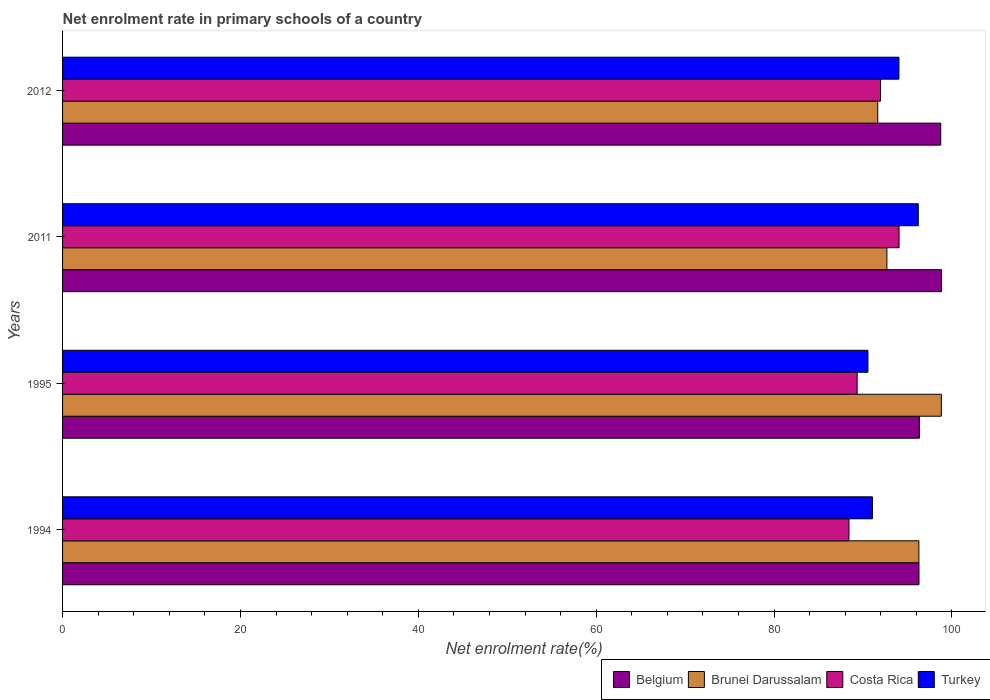How many groups of bars are there?
Make the answer very short. 4. Are the number of bars per tick equal to the number of legend labels?
Provide a short and direct response. Yes. Are the number of bars on each tick of the Y-axis equal?
Provide a succinct answer. Yes. In how many cases, is the number of bars for a given year not equal to the number of legend labels?
Provide a short and direct response. 0. What is the net enrolment rate in primary schools in Belgium in 1994?
Offer a very short reply. 96.3. Across all years, what is the maximum net enrolment rate in primary schools in Brunei Darussalam?
Give a very brief answer. 98.81. Across all years, what is the minimum net enrolment rate in primary schools in Turkey?
Keep it short and to the point. 90.56. What is the total net enrolment rate in primary schools in Turkey in the graph?
Give a very brief answer. 371.87. What is the difference between the net enrolment rate in primary schools in Belgium in 1994 and that in 2011?
Provide a succinct answer. -2.54. What is the difference between the net enrolment rate in primary schools in Turkey in 1995 and the net enrolment rate in primary schools in Brunei Darussalam in 2012?
Make the answer very short. -1.11. What is the average net enrolment rate in primary schools in Turkey per year?
Provide a short and direct response. 92.97. In the year 2012, what is the difference between the net enrolment rate in primary schools in Belgium and net enrolment rate in primary schools in Brunei Darussalam?
Your answer should be very brief. 7.08. What is the ratio of the net enrolment rate in primary schools in Costa Rica in 1995 to that in 2011?
Your answer should be very brief. 0.95. Is the difference between the net enrolment rate in primary schools in Belgium in 1995 and 2012 greater than the difference between the net enrolment rate in primary schools in Brunei Darussalam in 1995 and 2012?
Give a very brief answer. No. What is the difference between the highest and the second highest net enrolment rate in primary schools in Brunei Darussalam?
Your answer should be very brief. 2.53. What is the difference between the highest and the lowest net enrolment rate in primary schools in Belgium?
Provide a succinct answer. 2.54. In how many years, is the net enrolment rate in primary schools in Turkey greater than the average net enrolment rate in primary schools in Turkey taken over all years?
Your response must be concise. 2. Is the sum of the net enrolment rate in primary schools in Turkey in 1994 and 2012 greater than the maximum net enrolment rate in primary schools in Belgium across all years?
Keep it short and to the point. Yes. Is it the case that in every year, the sum of the net enrolment rate in primary schools in Costa Rica and net enrolment rate in primary schools in Turkey is greater than the sum of net enrolment rate in primary schools in Brunei Darussalam and net enrolment rate in primary schools in Belgium?
Provide a short and direct response. No. What does the 2nd bar from the top in 1994 represents?
Keep it short and to the point. Costa Rica. What does the 3rd bar from the bottom in 2011 represents?
Keep it short and to the point. Costa Rica. Is it the case that in every year, the sum of the net enrolment rate in primary schools in Belgium and net enrolment rate in primary schools in Turkey is greater than the net enrolment rate in primary schools in Brunei Darussalam?
Your answer should be compact. Yes. How many bars are there?
Keep it short and to the point. 16. Are all the bars in the graph horizontal?
Keep it short and to the point. Yes. What is the difference between two consecutive major ticks on the X-axis?
Your answer should be very brief. 20. Are the values on the major ticks of X-axis written in scientific E-notation?
Your answer should be very brief. No. Where does the legend appear in the graph?
Ensure brevity in your answer.  Bottom right. How are the legend labels stacked?
Give a very brief answer. Horizontal. What is the title of the graph?
Your answer should be compact. Net enrolment rate in primary schools of a country. What is the label or title of the X-axis?
Keep it short and to the point. Net enrolment rate(%). What is the label or title of the Y-axis?
Your response must be concise. Years. What is the Net enrolment rate(%) in Belgium in 1994?
Your answer should be compact. 96.3. What is the Net enrolment rate(%) in Brunei Darussalam in 1994?
Offer a very short reply. 96.28. What is the Net enrolment rate(%) in Costa Rica in 1994?
Ensure brevity in your answer.  88.42. What is the Net enrolment rate(%) in Turkey in 1994?
Give a very brief answer. 91.06. What is the Net enrolment rate(%) in Belgium in 1995?
Provide a succinct answer. 96.34. What is the Net enrolment rate(%) in Brunei Darussalam in 1995?
Ensure brevity in your answer.  98.81. What is the Net enrolment rate(%) of Costa Rica in 1995?
Make the answer very short. 89.34. What is the Net enrolment rate(%) of Turkey in 1995?
Keep it short and to the point. 90.56. What is the Net enrolment rate(%) in Belgium in 2011?
Offer a terse response. 98.83. What is the Net enrolment rate(%) of Brunei Darussalam in 2011?
Your answer should be very brief. 92.69. What is the Net enrolment rate(%) of Costa Rica in 2011?
Your response must be concise. 94.06. What is the Net enrolment rate(%) in Turkey in 2011?
Your answer should be very brief. 96.22. What is the Net enrolment rate(%) in Belgium in 2012?
Ensure brevity in your answer.  98.74. What is the Net enrolment rate(%) of Brunei Darussalam in 2012?
Provide a short and direct response. 91.66. What is the Net enrolment rate(%) of Costa Rica in 2012?
Keep it short and to the point. 91.98. What is the Net enrolment rate(%) of Turkey in 2012?
Make the answer very short. 94.04. Across all years, what is the maximum Net enrolment rate(%) in Belgium?
Ensure brevity in your answer.  98.83. Across all years, what is the maximum Net enrolment rate(%) in Brunei Darussalam?
Offer a very short reply. 98.81. Across all years, what is the maximum Net enrolment rate(%) of Costa Rica?
Make the answer very short. 94.06. Across all years, what is the maximum Net enrolment rate(%) of Turkey?
Keep it short and to the point. 96.22. Across all years, what is the minimum Net enrolment rate(%) of Belgium?
Provide a succinct answer. 96.3. Across all years, what is the minimum Net enrolment rate(%) in Brunei Darussalam?
Your response must be concise. 91.66. Across all years, what is the minimum Net enrolment rate(%) of Costa Rica?
Provide a short and direct response. 88.42. Across all years, what is the minimum Net enrolment rate(%) in Turkey?
Your response must be concise. 90.56. What is the total Net enrolment rate(%) in Belgium in the graph?
Give a very brief answer. 390.21. What is the total Net enrolment rate(%) in Brunei Darussalam in the graph?
Provide a short and direct response. 379.44. What is the total Net enrolment rate(%) of Costa Rica in the graph?
Make the answer very short. 363.8. What is the total Net enrolment rate(%) of Turkey in the graph?
Your answer should be very brief. 371.87. What is the difference between the Net enrolment rate(%) of Belgium in 1994 and that in 1995?
Offer a terse response. -0.05. What is the difference between the Net enrolment rate(%) in Brunei Darussalam in 1994 and that in 1995?
Provide a succinct answer. -2.53. What is the difference between the Net enrolment rate(%) in Costa Rica in 1994 and that in 1995?
Your response must be concise. -0.92. What is the difference between the Net enrolment rate(%) of Turkey in 1994 and that in 1995?
Provide a short and direct response. 0.5. What is the difference between the Net enrolment rate(%) in Belgium in 1994 and that in 2011?
Give a very brief answer. -2.54. What is the difference between the Net enrolment rate(%) in Brunei Darussalam in 1994 and that in 2011?
Offer a very short reply. 3.6. What is the difference between the Net enrolment rate(%) in Costa Rica in 1994 and that in 2011?
Your answer should be very brief. -5.63. What is the difference between the Net enrolment rate(%) in Turkey in 1994 and that in 2011?
Provide a short and direct response. -5.16. What is the difference between the Net enrolment rate(%) of Belgium in 1994 and that in 2012?
Your answer should be very brief. -2.45. What is the difference between the Net enrolment rate(%) in Brunei Darussalam in 1994 and that in 2012?
Give a very brief answer. 4.62. What is the difference between the Net enrolment rate(%) of Costa Rica in 1994 and that in 2012?
Your answer should be very brief. -3.55. What is the difference between the Net enrolment rate(%) in Turkey in 1994 and that in 2012?
Provide a succinct answer. -2.98. What is the difference between the Net enrolment rate(%) of Belgium in 1995 and that in 2011?
Your answer should be very brief. -2.49. What is the difference between the Net enrolment rate(%) of Brunei Darussalam in 1995 and that in 2011?
Give a very brief answer. 6.12. What is the difference between the Net enrolment rate(%) in Costa Rica in 1995 and that in 2011?
Your response must be concise. -4.71. What is the difference between the Net enrolment rate(%) of Turkey in 1995 and that in 2011?
Your answer should be compact. -5.66. What is the difference between the Net enrolment rate(%) of Belgium in 1995 and that in 2012?
Offer a terse response. -2.4. What is the difference between the Net enrolment rate(%) in Brunei Darussalam in 1995 and that in 2012?
Your response must be concise. 7.15. What is the difference between the Net enrolment rate(%) in Costa Rica in 1995 and that in 2012?
Offer a very short reply. -2.63. What is the difference between the Net enrolment rate(%) in Turkey in 1995 and that in 2012?
Your response must be concise. -3.49. What is the difference between the Net enrolment rate(%) of Belgium in 2011 and that in 2012?
Offer a very short reply. 0.09. What is the difference between the Net enrolment rate(%) in Brunei Darussalam in 2011 and that in 2012?
Your response must be concise. 1.03. What is the difference between the Net enrolment rate(%) of Costa Rica in 2011 and that in 2012?
Your answer should be compact. 2.08. What is the difference between the Net enrolment rate(%) of Turkey in 2011 and that in 2012?
Give a very brief answer. 2.18. What is the difference between the Net enrolment rate(%) in Belgium in 1994 and the Net enrolment rate(%) in Brunei Darussalam in 1995?
Your answer should be compact. -2.51. What is the difference between the Net enrolment rate(%) in Belgium in 1994 and the Net enrolment rate(%) in Costa Rica in 1995?
Make the answer very short. 6.95. What is the difference between the Net enrolment rate(%) in Belgium in 1994 and the Net enrolment rate(%) in Turkey in 1995?
Offer a terse response. 5.74. What is the difference between the Net enrolment rate(%) of Brunei Darussalam in 1994 and the Net enrolment rate(%) of Costa Rica in 1995?
Your response must be concise. 6.94. What is the difference between the Net enrolment rate(%) of Brunei Darussalam in 1994 and the Net enrolment rate(%) of Turkey in 1995?
Provide a short and direct response. 5.73. What is the difference between the Net enrolment rate(%) in Costa Rica in 1994 and the Net enrolment rate(%) in Turkey in 1995?
Your answer should be compact. -2.13. What is the difference between the Net enrolment rate(%) in Belgium in 1994 and the Net enrolment rate(%) in Brunei Darussalam in 2011?
Offer a terse response. 3.61. What is the difference between the Net enrolment rate(%) of Belgium in 1994 and the Net enrolment rate(%) of Costa Rica in 2011?
Provide a succinct answer. 2.24. What is the difference between the Net enrolment rate(%) in Belgium in 1994 and the Net enrolment rate(%) in Turkey in 2011?
Provide a succinct answer. 0.08. What is the difference between the Net enrolment rate(%) in Brunei Darussalam in 1994 and the Net enrolment rate(%) in Costa Rica in 2011?
Provide a short and direct response. 2.23. What is the difference between the Net enrolment rate(%) in Brunei Darussalam in 1994 and the Net enrolment rate(%) in Turkey in 2011?
Ensure brevity in your answer.  0.07. What is the difference between the Net enrolment rate(%) of Costa Rica in 1994 and the Net enrolment rate(%) of Turkey in 2011?
Your response must be concise. -7.8. What is the difference between the Net enrolment rate(%) of Belgium in 1994 and the Net enrolment rate(%) of Brunei Darussalam in 2012?
Your answer should be compact. 4.64. What is the difference between the Net enrolment rate(%) of Belgium in 1994 and the Net enrolment rate(%) of Costa Rica in 2012?
Make the answer very short. 4.32. What is the difference between the Net enrolment rate(%) of Belgium in 1994 and the Net enrolment rate(%) of Turkey in 2012?
Give a very brief answer. 2.25. What is the difference between the Net enrolment rate(%) of Brunei Darussalam in 1994 and the Net enrolment rate(%) of Costa Rica in 2012?
Your response must be concise. 4.31. What is the difference between the Net enrolment rate(%) of Brunei Darussalam in 1994 and the Net enrolment rate(%) of Turkey in 2012?
Keep it short and to the point. 2.24. What is the difference between the Net enrolment rate(%) in Costa Rica in 1994 and the Net enrolment rate(%) in Turkey in 2012?
Your response must be concise. -5.62. What is the difference between the Net enrolment rate(%) of Belgium in 1995 and the Net enrolment rate(%) of Brunei Darussalam in 2011?
Keep it short and to the point. 3.65. What is the difference between the Net enrolment rate(%) in Belgium in 1995 and the Net enrolment rate(%) in Costa Rica in 2011?
Your answer should be very brief. 2.29. What is the difference between the Net enrolment rate(%) of Belgium in 1995 and the Net enrolment rate(%) of Turkey in 2011?
Your answer should be compact. 0.12. What is the difference between the Net enrolment rate(%) of Brunei Darussalam in 1995 and the Net enrolment rate(%) of Costa Rica in 2011?
Keep it short and to the point. 4.75. What is the difference between the Net enrolment rate(%) in Brunei Darussalam in 1995 and the Net enrolment rate(%) in Turkey in 2011?
Give a very brief answer. 2.59. What is the difference between the Net enrolment rate(%) of Costa Rica in 1995 and the Net enrolment rate(%) of Turkey in 2011?
Ensure brevity in your answer.  -6.87. What is the difference between the Net enrolment rate(%) of Belgium in 1995 and the Net enrolment rate(%) of Brunei Darussalam in 2012?
Provide a short and direct response. 4.68. What is the difference between the Net enrolment rate(%) of Belgium in 1995 and the Net enrolment rate(%) of Costa Rica in 2012?
Your response must be concise. 4.37. What is the difference between the Net enrolment rate(%) of Belgium in 1995 and the Net enrolment rate(%) of Turkey in 2012?
Your answer should be very brief. 2.3. What is the difference between the Net enrolment rate(%) in Brunei Darussalam in 1995 and the Net enrolment rate(%) in Costa Rica in 2012?
Your answer should be very brief. 6.83. What is the difference between the Net enrolment rate(%) in Brunei Darussalam in 1995 and the Net enrolment rate(%) in Turkey in 2012?
Provide a short and direct response. 4.77. What is the difference between the Net enrolment rate(%) of Costa Rica in 1995 and the Net enrolment rate(%) of Turkey in 2012?
Your answer should be compact. -4.7. What is the difference between the Net enrolment rate(%) in Belgium in 2011 and the Net enrolment rate(%) in Brunei Darussalam in 2012?
Ensure brevity in your answer.  7.17. What is the difference between the Net enrolment rate(%) in Belgium in 2011 and the Net enrolment rate(%) in Costa Rica in 2012?
Your answer should be compact. 6.86. What is the difference between the Net enrolment rate(%) in Belgium in 2011 and the Net enrolment rate(%) in Turkey in 2012?
Give a very brief answer. 4.79. What is the difference between the Net enrolment rate(%) in Brunei Darussalam in 2011 and the Net enrolment rate(%) in Costa Rica in 2012?
Provide a short and direct response. 0.71. What is the difference between the Net enrolment rate(%) of Brunei Darussalam in 2011 and the Net enrolment rate(%) of Turkey in 2012?
Offer a terse response. -1.35. What is the difference between the Net enrolment rate(%) in Costa Rica in 2011 and the Net enrolment rate(%) in Turkey in 2012?
Your answer should be very brief. 0.01. What is the average Net enrolment rate(%) of Belgium per year?
Your response must be concise. 97.55. What is the average Net enrolment rate(%) of Brunei Darussalam per year?
Provide a succinct answer. 94.86. What is the average Net enrolment rate(%) of Costa Rica per year?
Your answer should be compact. 90.95. What is the average Net enrolment rate(%) of Turkey per year?
Make the answer very short. 92.97. In the year 1994, what is the difference between the Net enrolment rate(%) in Belgium and Net enrolment rate(%) in Brunei Darussalam?
Make the answer very short. 0.01. In the year 1994, what is the difference between the Net enrolment rate(%) in Belgium and Net enrolment rate(%) in Costa Rica?
Provide a succinct answer. 7.87. In the year 1994, what is the difference between the Net enrolment rate(%) of Belgium and Net enrolment rate(%) of Turkey?
Keep it short and to the point. 5.24. In the year 1994, what is the difference between the Net enrolment rate(%) of Brunei Darussalam and Net enrolment rate(%) of Costa Rica?
Make the answer very short. 7.86. In the year 1994, what is the difference between the Net enrolment rate(%) in Brunei Darussalam and Net enrolment rate(%) in Turkey?
Keep it short and to the point. 5.22. In the year 1994, what is the difference between the Net enrolment rate(%) of Costa Rica and Net enrolment rate(%) of Turkey?
Keep it short and to the point. -2.64. In the year 1995, what is the difference between the Net enrolment rate(%) in Belgium and Net enrolment rate(%) in Brunei Darussalam?
Ensure brevity in your answer.  -2.47. In the year 1995, what is the difference between the Net enrolment rate(%) in Belgium and Net enrolment rate(%) in Costa Rica?
Provide a succinct answer. 7. In the year 1995, what is the difference between the Net enrolment rate(%) in Belgium and Net enrolment rate(%) in Turkey?
Your answer should be compact. 5.79. In the year 1995, what is the difference between the Net enrolment rate(%) of Brunei Darussalam and Net enrolment rate(%) of Costa Rica?
Keep it short and to the point. 9.47. In the year 1995, what is the difference between the Net enrolment rate(%) of Brunei Darussalam and Net enrolment rate(%) of Turkey?
Your response must be concise. 8.25. In the year 1995, what is the difference between the Net enrolment rate(%) of Costa Rica and Net enrolment rate(%) of Turkey?
Give a very brief answer. -1.21. In the year 2011, what is the difference between the Net enrolment rate(%) of Belgium and Net enrolment rate(%) of Brunei Darussalam?
Provide a succinct answer. 6.14. In the year 2011, what is the difference between the Net enrolment rate(%) in Belgium and Net enrolment rate(%) in Costa Rica?
Keep it short and to the point. 4.78. In the year 2011, what is the difference between the Net enrolment rate(%) of Belgium and Net enrolment rate(%) of Turkey?
Your answer should be very brief. 2.61. In the year 2011, what is the difference between the Net enrolment rate(%) in Brunei Darussalam and Net enrolment rate(%) in Costa Rica?
Keep it short and to the point. -1.37. In the year 2011, what is the difference between the Net enrolment rate(%) of Brunei Darussalam and Net enrolment rate(%) of Turkey?
Make the answer very short. -3.53. In the year 2011, what is the difference between the Net enrolment rate(%) in Costa Rica and Net enrolment rate(%) in Turkey?
Give a very brief answer. -2.16. In the year 2012, what is the difference between the Net enrolment rate(%) of Belgium and Net enrolment rate(%) of Brunei Darussalam?
Your answer should be very brief. 7.08. In the year 2012, what is the difference between the Net enrolment rate(%) in Belgium and Net enrolment rate(%) in Costa Rica?
Offer a very short reply. 6.77. In the year 2012, what is the difference between the Net enrolment rate(%) in Belgium and Net enrolment rate(%) in Turkey?
Give a very brief answer. 4.7. In the year 2012, what is the difference between the Net enrolment rate(%) in Brunei Darussalam and Net enrolment rate(%) in Costa Rica?
Offer a terse response. -0.32. In the year 2012, what is the difference between the Net enrolment rate(%) of Brunei Darussalam and Net enrolment rate(%) of Turkey?
Your answer should be very brief. -2.38. In the year 2012, what is the difference between the Net enrolment rate(%) of Costa Rica and Net enrolment rate(%) of Turkey?
Give a very brief answer. -2.06. What is the ratio of the Net enrolment rate(%) in Brunei Darussalam in 1994 to that in 1995?
Ensure brevity in your answer.  0.97. What is the ratio of the Net enrolment rate(%) in Turkey in 1994 to that in 1995?
Keep it short and to the point. 1.01. What is the ratio of the Net enrolment rate(%) in Belgium in 1994 to that in 2011?
Ensure brevity in your answer.  0.97. What is the ratio of the Net enrolment rate(%) in Brunei Darussalam in 1994 to that in 2011?
Ensure brevity in your answer.  1.04. What is the ratio of the Net enrolment rate(%) in Costa Rica in 1994 to that in 2011?
Offer a very short reply. 0.94. What is the ratio of the Net enrolment rate(%) of Turkey in 1994 to that in 2011?
Keep it short and to the point. 0.95. What is the ratio of the Net enrolment rate(%) of Belgium in 1994 to that in 2012?
Your answer should be compact. 0.98. What is the ratio of the Net enrolment rate(%) of Brunei Darussalam in 1994 to that in 2012?
Provide a short and direct response. 1.05. What is the ratio of the Net enrolment rate(%) in Costa Rica in 1994 to that in 2012?
Your response must be concise. 0.96. What is the ratio of the Net enrolment rate(%) of Turkey in 1994 to that in 2012?
Offer a terse response. 0.97. What is the ratio of the Net enrolment rate(%) of Belgium in 1995 to that in 2011?
Your answer should be very brief. 0.97. What is the ratio of the Net enrolment rate(%) of Brunei Darussalam in 1995 to that in 2011?
Your answer should be compact. 1.07. What is the ratio of the Net enrolment rate(%) of Costa Rica in 1995 to that in 2011?
Provide a succinct answer. 0.95. What is the ratio of the Net enrolment rate(%) of Turkey in 1995 to that in 2011?
Give a very brief answer. 0.94. What is the ratio of the Net enrolment rate(%) of Belgium in 1995 to that in 2012?
Provide a short and direct response. 0.98. What is the ratio of the Net enrolment rate(%) of Brunei Darussalam in 1995 to that in 2012?
Provide a short and direct response. 1.08. What is the ratio of the Net enrolment rate(%) in Costa Rica in 1995 to that in 2012?
Keep it short and to the point. 0.97. What is the ratio of the Net enrolment rate(%) of Turkey in 1995 to that in 2012?
Your answer should be compact. 0.96. What is the ratio of the Net enrolment rate(%) of Belgium in 2011 to that in 2012?
Your response must be concise. 1. What is the ratio of the Net enrolment rate(%) of Brunei Darussalam in 2011 to that in 2012?
Keep it short and to the point. 1.01. What is the ratio of the Net enrolment rate(%) in Costa Rica in 2011 to that in 2012?
Make the answer very short. 1.02. What is the ratio of the Net enrolment rate(%) of Turkey in 2011 to that in 2012?
Offer a very short reply. 1.02. What is the difference between the highest and the second highest Net enrolment rate(%) in Belgium?
Offer a very short reply. 0.09. What is the difference between the highest and the second highest Net enrolment rate(%) in Brunei Darussalam?
Your answer should be very brief. 2.53. What is the difference between the highest and the second highest Net enrolment rate(%) in Costa Rica?
Make the answer very short. 2.08. What is the difference between the highest and the second highest Net enrolment rate(%) of Turkey?
Provide a short and direct response. 2.18. What is the difference between the highest and the lowest Net enrolment rate(%) of Belgium?
Give a very brief answer. 2.54. What is the difference between the highest and the lowest Net enrolment rate(%) in Brunei Darussalam?
Ensure brevity in your answer.  7.15. What is the difference between the highest and the lowest Net enrolment rate(%) of Costa Rica?
Your answer should be very brief. 5.63. What is the difference between the highest and the lowest Net enrolment rate(%) of Turkey?
Your answer should be compact. 5.66. 